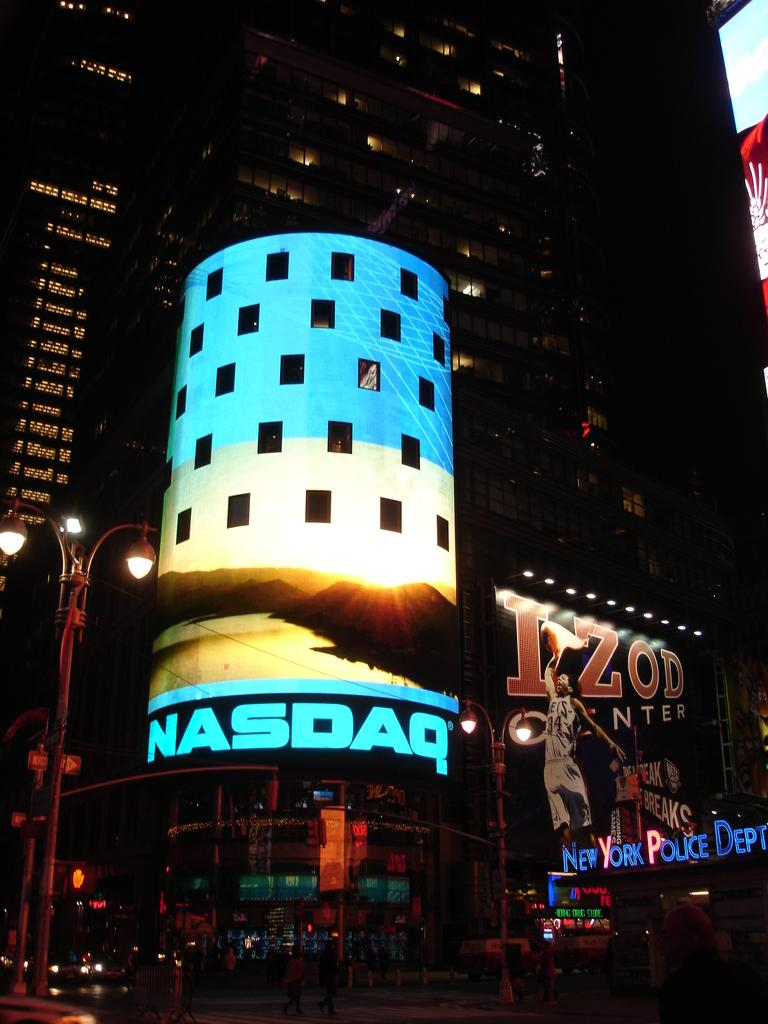What is the condition of the buildings in the image? The buildings in the image are lighted up. How would you describe the overall setting of the image? The image is set in a dark environment. What can be seen on the road in the image? There are vehicles on the road in the image. Can you identify any other light sources in the image besides the buildings? Yes, there is a street light on the side of the road in the image. What type of sheet is being used for scientific learning in the image? There is no sheet or scientific learning present in the image; it features lighted-up buildings, a dark environment, vehicles on the road, and a street light. 